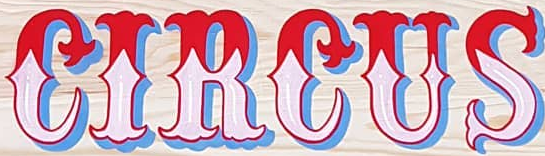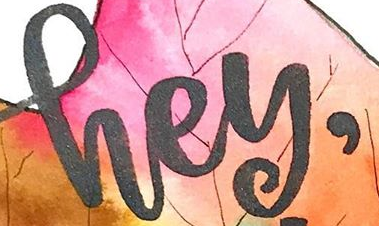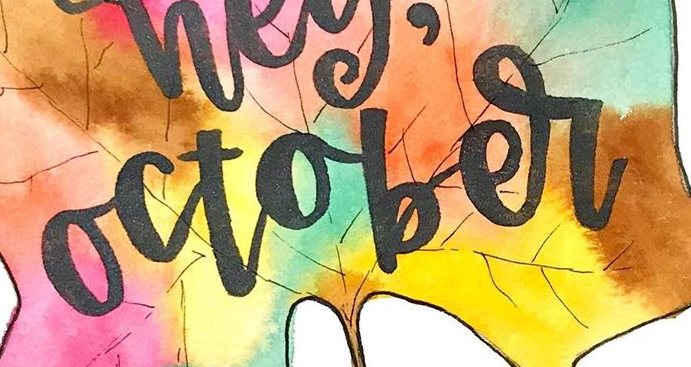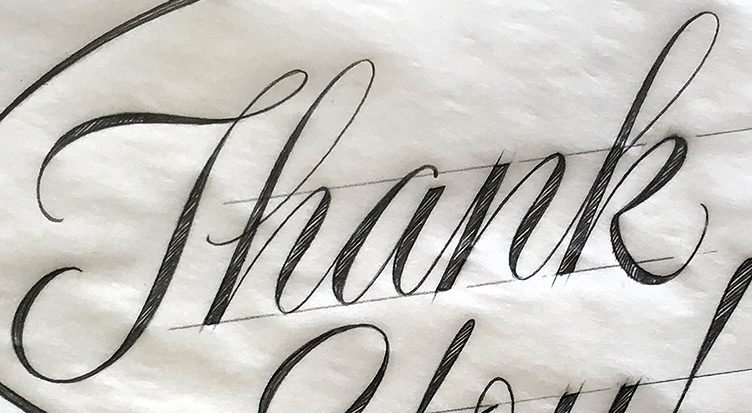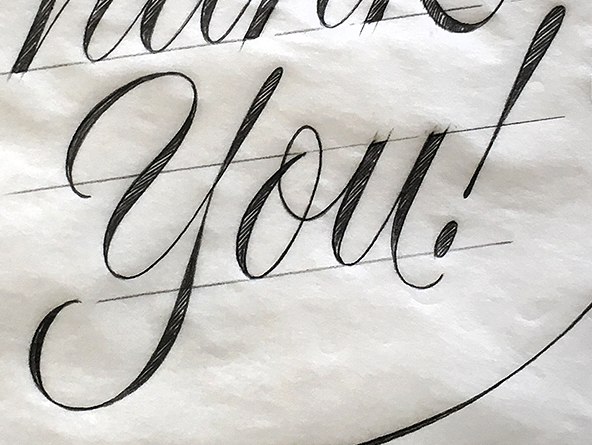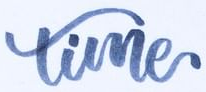Identify the words shown in these images in order, separated by a semicolon. CIRCUS; hey,; october; Thank; you!; time 